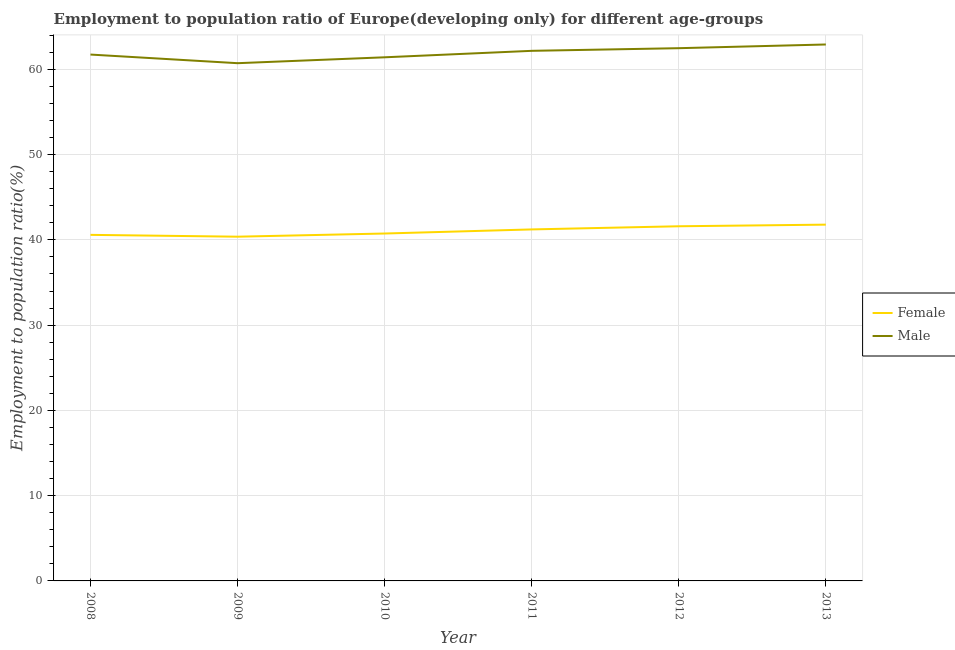What is the employment to population ratio(female) in 2011?
Give a very brief answer. 41.22. Across all years, what is the maximum employment to population ratio(female)?
Keep it short and to the point. 41.79. Across all years, what is the minimum employment to population ratio(male)?
Offer a terse response. 60.72. In which year was the employment to population ratio(male) maximum?
Your answer should be very brief. 2013. What is the total employment to population ratio(male) in the graph?
Your response must be concise. 371.43. What is the difference between the employment to population ratio(male) in 2009 and that in 2013?
Give a very brief answer. -2.19. What is the difference between the employment to population ratio(male) in 2012 and the employment to population ratio(female) in 2013?
Your answer should be compact. 20.69. What is the average employment to population ratio(female) per year?
Offer a terse response. 41.05. In the year 2012, what is the difference between the employment to population ratio(female) and employment to population ratio(male)?
Your answer should be very brief. -20.89. In how many years, is the employment to population ratio(female) greater than 2 %?
Ensure brevity in your answer.  6. What is the ratio of the employment to population ratio(female) in 2009 to that in 2010?
Provide a succinct answer. 0.99. Is the employment to population ratio(male) in 2010 less than that in 2011?
Ensure brevity in your answer.  Yes. Is the difference between the employment to population ratio(male) in 2009 and 2010 greater than the difference between the employment to population ratio(female) in 2009 and 2010?
Provide a succinct answer. No. What is the difference between the highest and the second highest employment to population ratio(male)?
Provide a short and direct response. 0.43. What is the difference between the highest and the lowest employment to population ratio(male)?
Your answer should be compact. 2.19. In how many years, is the employment to population ratio(male) greater than the average employment to population ratio(male) taken over all years?
Offer a terse response. 3. How many years are there in the graph?
Give a very brief answer. 6. Does the graph contain any zero values?
Your answer should be compact. No. What is the title of the graph?
Your answer should be compact. Employment to population ratio of Europe(developing only) for different age-groups. What is the label or title of the X-axis?
Give a very brief answer. Year. What is the Employment to population ratio(%) of Female in 2008?
Your response must be concise. 40.59. What is the Employment to population ratio(%) in Male in 2008?
Keep it short and to the point. 61.73. What is the Employment to population ratio(%) of Female in 2009?
Offer a very short reply. 40.37. What is the Employment to population ratio(%) in Male in 2009?
Make the answer very short. 60.72. What is the Employment to population ratio(%) in Female in 2010?
Your answer should be very brief. 40.74. What is the Employment to population ratio(%) of Male in 2010?
Your answer should be compact. 61.41. What is the Employment to population ratio(%) in Female in 2011?
Keep it short and to the point. 41.22. What is the Employment to population ratio(%) of Male in 2011?
Your response must be concise. 62.17. What is the Employment to population ratio(%) of Female in 2012?
Your response must be concise. 41.59. What is the Employment to population ratio(%) in Male in 2012?
Your answer should be very brief. 62.48. What is the Employment to population ratio(%) of Female in 2013?
Keep it short and to the point. 41.79. What is the Employment to population ratio(%) of Male in 2013?
Your answer should be compact. 62.91. Across all years, what is the maximum Employment to population ratio(%) of Female?
Provide a short and direct response. 41.79. Across all years, what is the maximum Employment to population ratio(%) of Male?
Provide a succinct answer. 62.91. Across all years, what is the minimum Employment to population ratio(%) of Female?
Make the answer very short. 40.37. Across all years, what is the minimum Employment to population ratio(%) of Male?
Keep it short and to the point. 60.72. What is the total Employment to population ratio(%) in Female in the graph?
Ensure brevity in your answer.  246.31. What is the total Employment to population ratio(%) of Male in the graph?
Offer a very short reply. 371.43. What is the difference between the Employment to population ratio(%) of Female in 2008 and that in 2009?
Offer a very short reply. 0.22. What is the difference between the Employment to population ratio(%) in Male in 2008 and that in 2009?
Give a very brief answer. 1.01. What is the difference between the Employment to population ratio(%) in Female in 2008 and that in 2010?
Your response must be concise. -0.16. What is the difference between the Employment to population ratio(%) of Male in 2008 and that in 2010?
Make the answer very short. 0.32. What is the difference between the Employment to population ratio(%) in Female in 2008 and that in 2011?
Your response must be concise. -0.64. What is the difference between the Employment to population ratio(%) of Male in 2008 and that in 2011?
Give a very brief answer. -0.44. What is the difference between the Employment to population ratio(%) in Female in 2008 and that in 2012?
Offer a terse response. -1.01. What is the difference between the Employment to population ratio(%) in Male in 2008 and that in 2012?
Offer a very short reply. -0.75. What is the difference between the Employment to population ratio(%) of Female in 2008 and that in 2013?
Provide a succinct answer. -1.2. What is the difference between the Employment to population ratio(%) in Male in 2008 and that in 2013?
Make the answer very short. -1.18. What is the difference between the Employment to population ratio(%) of Female in 2009 and that in 2010?
Ensure brevity in your answer.  -0.37. What is the difference between the Employment to population ratio(%) of Male in 2009 and that in 2010?
Your response must be concise. -0.69. What is the difference between the Employment to population ratio(%) in Female in 2009 and that in 2011?
Offer a very short reply. -0.85. What is the difference between the Employment to population ratio(%) of Male in 2009 and that in 2011?
Your answer should be compact. -1.45. What is the difference between the Employment to population ratio(%) of Female in 2009 and that in 2012?
Your answer should be very brief. -1.22. What is the difference between the Employment to population ratio(%) in Male in 2009 and that in 2012?
Ensure brevity in your answer.  -1.76. What is the difference between the Employment to population ratio(%) of Female in 2009 and that in 2013?
Make the answer very short. -1.41. What is the difference between the Employment to population ratio(%) in Male in 2009 and that in 2013?
Offer a terse response. -2.19. What is the difference between the Employment to population ratio(%) of Female in 2010 and that in 2011?
Keep it short and to the point. -0.48. What is the difference between the Employment to population ratio(%) of Male in 2010 and that in 2011?
Provide a short and direct response. -0.76. What is the difference between the Employment to population ratio(%) of Female in 2010 and that in 2012?
Your response must be concise. -0.85. What is the difference between the Employment to population ratio(%) of Male in 2010 and that in 2012?
Ensure brevity in your answer.  -1.07. What is the difference between the Employment to population ratio(%) in Female in 2010 and that in 2013?
Offer a very short reply. -1.04. What is the difference between the Employment to population ratio(%) of Male in 2010 and that in 2013?
Offer a terse response. -1.5. What is the difference between the Employment to population ratio(%) of Female in 2011 and that in 2012?
Give a very brief answer. -0.37. What is the difference between the Employment to population ratio(%) of Male in 2011 and that in 2012?
Ensure brevity in your answer.  -0.31. What is the difference between the Employment to population ratio(%) in Female in 2011 and that in 2013?
Provide a short and direct response. -0.56. What is the difference between the Employment to population ratio(%) of Male in 2011 and that in 2013?
Your answer should be very brief. -0.74. What is the difference between the Employment to population ratio(%) of Female in 2012 and that in 2013?
Ensure brevity in your answer.  -0.19. What is the difference between the Employment to population ratio(%) in Male in 2012 and that in 2013?
Your answer should be compact. -0.43. What is the difference between the Employment to population ratio(%) in Female in 2008 and the Employment to population ratio(%) in Male in 2009?
Make the answer very short. -20.13. What is the difference between the Employment to population ratio(%) of Female in 2008 and the Employment to population ratio(%) of Male in 2010?
Provide a succinct answer. -20.82. What is the difference between the Employment to population ratio(%) in Female in 2008 and the Employment to population ratio(%) in Male in 2011?
Offer a very short reply. -21.58. What is the difference between the Employment to population ratio(%) in Female in 2008 and the Employment to population ratio(%) in Male in 2012?
Provide a succinct answer. -21.89. What is the difference between the Employment to population ratio(%) in Female in 2008 and the Employment to population ratio(%) in Male in 2013?
Give a very brief answer. -22.33. What is the difference between the Employment to population ratio(%) of Female in 2009 and the Employment to population ratio(%) of Male in 2010?
Your response must be concise. -21.04. What is the difference between the Employment to population ratio(%) in Female in 2009 and the Employment to population ratio(%) in Male in 2011?
Provide a succinct answer. -21.8. What is the difference between the Employment to population ratio(%) in Female in 2009 and the Employment to population ratio(%) in Male in 2012?
Your answer should be very brief. -22.11. What is the difference between the Employment to population ratio(%) of Female in 2009 and the Employment to population ratio(%) of Male in 2013?
Give a very brief answer. -22.54. What is the difference between the Employment to population ratio(%) of Female in 2010 and the Employment to population ratio(%) of Male in 2011?
Provide a succinct answer. -21.43. What is the difference between the Employment to population ratio(%) in Female in 2010 and the Employment to population ratio(%) in Male in 2012?
Ensure brevity in your answer.  -21.74. What is the difference between the Employment to population ratio(%) of Female in 2010 and the Employment to population ratio(%) of Male in 2013?
Make the answer very short. -22.17. What is the difference between the Employment to population ratio(%) of Female in 2011 and the Employment to population ratio(%) of Male in 2012?
Your answer should be compact. -21.26. What is the difference between the Employment to population ratio(%) of Female in 2011 and the Employment to population ratio(%) of Male in 2013?
Offer a very short reply. -21.69. What is the difference between the Employment to population ratio(%) in Female in 2012 and the Employment to population ratio(%) in Male in 2013?
Ensure brevity in your answer.  -21.32. What is the average Employment to population ratio(%) in Female per year?
Offer a very short reply. 41.05. What is the average Employment to population ratio(%) of Male per year?
Provide a succinct answer. 61.91. In the year 2008, what is the difference between the Employment to population ratio(%) of Female and Employment to population ratio(%) of Male?
Provide a short and direct response. -21.15. In the year 2009, what is the difference between the Employment to population ratio(%) in Female and Employment to population ratio(%) in Male?
Provide a short and direct response. -20.35. In the year 2010, what is the difference between the Employment to population ratio(%) of Female and Employment to population ratio(%) of Male?
Keep it short and to the point. -20.67. In the year 2011, what is the difference between the Employment to population ratio(%) in Female and Employment to population ratio(%) in Male?
Provide a succinct answer. -20.95. In the year 2012, what is the difference between the Employment to population ratio(%) in Female and Employment to population ratio(%) in Male?
Make the answer very short. -20.89. In the year 2013, what is the difference between the Employment to population ratio(%) of Female and Employment to population ratio(%) of Male?
Your answer should be very brief. -21.13. What is the ratio of the Employment to population ratio(%) of Female in 2008 to that in 2009?
Give a very brief answer. 1.01. What is the ratio of the Employment to population ratio(%) in Male in 2008 to that in 2009?
Your answer should be compact. 1.02. What is the ratio of the Employment to population ratio(%) in Female in 2008 to that in 2010?
Provide a short and direct response. 1. What is the ratio of the Employment to population ratio(%) in Female in 2008 to that in 2011?
Provide a short and direct response. 0.98. What is the ratio of the Employment to population ratio(%) of Male in 2008 to that in 2011?
Your answer should be very brief. 0.99. What is the ratio of the Employment to population ratio(%) of Female in 2008 to that in 2012?
Offer a terse response. 0.98. What is the ratio of the Employment to population ratio(%) of Male in 2008 to that in 2012?
Provide a short and direct response. 0.99. What is the ratio of the Employment to population ratio(%) in Female in 2008 to that in 2013?
Your response must be concise. 0.97. What is the ratio of the Employment to population ratio(%) of Male in 2008 to that in 2013?
Keep it short and to the point. 0.98. What is the ratio of the Employment to population ratio(%) in Female in 2009 to that in 2010?
Make the answer very short. 0.99. What is the ratio of the Employment to population ratio(%) of Male in 2009 to that in 2010?
Offer a very short reply. 0.99. What is the ratio of the Employment to population ratio(%) of Female in 2009 to that in 2011?
Offer a very short reply. 0.98. What is the ratio of the Employment to population ratio(%) in Male in 2009 to that in 2011?
Offer a very short reply. 0.98. What is the ratio of the Employment to population ratio(%) of Female in 2009 to that in 2012?
Your response must be concise. 0.97. What is the ratio of the Employment to population ratio(%) of Male in 2009 to that in 2012?
Provide a succinct answer. 0.97. What is the ratio of the Employment to population ratio(%) of Female in 2009 to that in 2013?
Your response must be concise. 0.97. What is the ratio of the Employment to population ratio(%) of Male in 2009 to that in 2013?
Provide a short and direct response. 0.97. What is the ratio of the Employment to population ratio(%) of Female in 2010 to that in 2011?
Give a very brief answer. 0.99. What is the ratio of the Employment to population ratio(%) in Male in 2010 to that in 2011?
Offer a terse response. 0.99. What is the ratio of the Employment to population ratio(%) of Female in 2010 to that in 2012?
Make the answer very short. 0.98. What is the ratio of the Employment to population ratio(%) of Male in 2010 to that in 2012?
Give a very brief answer. 0.98. What is the ratio of the Employment to population ratio(%) in Female in 2010 to that in 2013?
Provide a short and direct response. 0.98. What is the ratio of the Employment to population ratio(%) in Male in 2010 to that in 2013?
Your answer should be compact. 0.98. What is the ratio of the Employment to population ratio(%) in Female in 2011 to that in 2013?
Provide a succinct answer. 0.99. What is the ratio of the Employment to population ratio(%) in Female in 2012 to that in 2013?
Offer a very short reply. 1. What is the difference between the highest and the second highest Employment to population ratio(%) of Female?
Your answer should be compact. 0.19. What is the difference between the highest and the second highest Employment to population ratio(%) of Male?
Offer a very short reply. 0.43. What is the difference between the highest and the lowest Employment to population ratio(%) in Female?
Keep it short and to the point. 1.41. What is the difference between the highest and the lowest Employment to population ratio(%) of Male?
Your answer should be very brief. 2.19. 